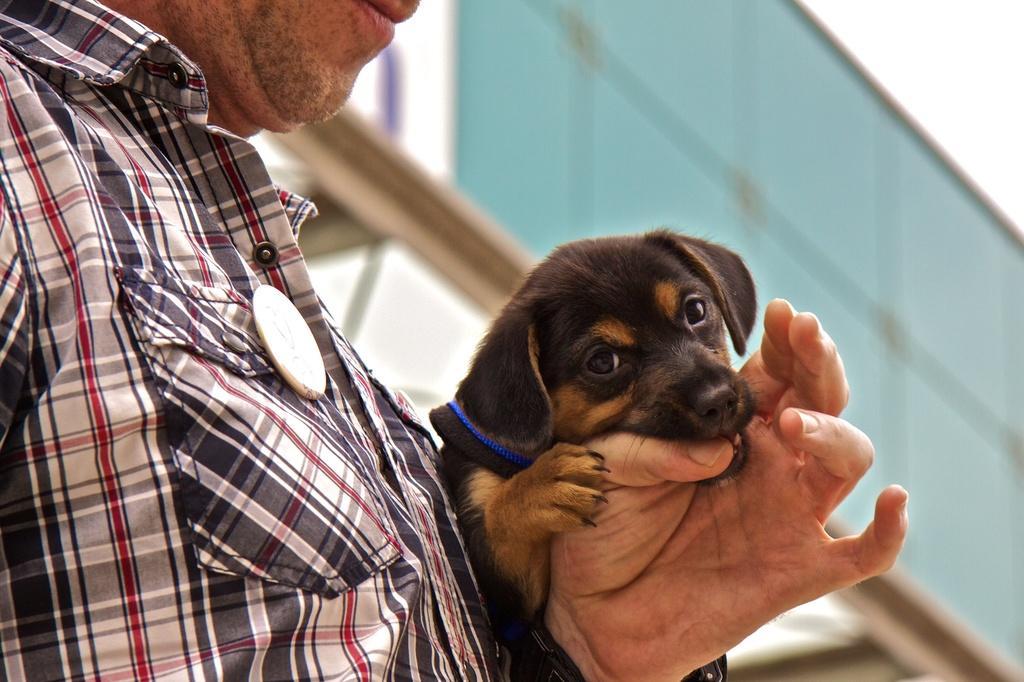In one or two sentences, can you explain what this image depicts? In the image there is a man holding a dog on his hand. 